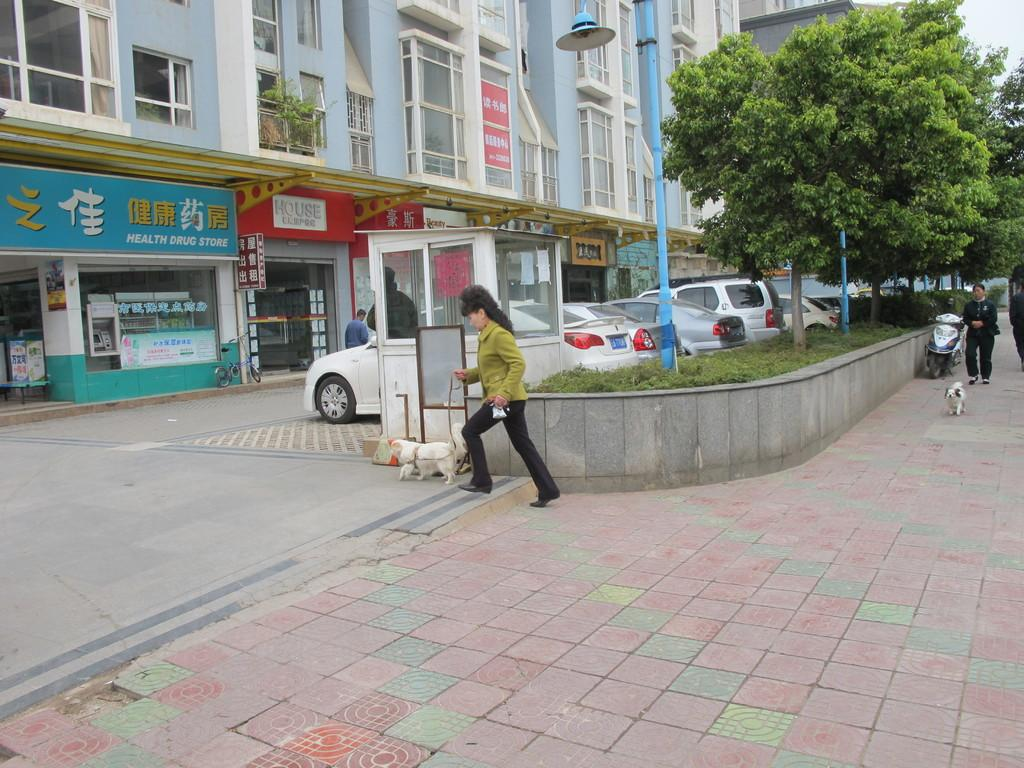What feature can be seen on the building in the image? The building has windows. What type of establishment is located in the building? There are stores in the building. What is present in front of the building? Trees, light poles, vehicles, and people are visible in front of the building. Can you describe the presence of a dog in the image? Yes, there is a dog in the image. What type of amusement can be seen in the image? There is no amusement present in the image; it features a building with stores, trees, light poles, vehicles, people, and a dog. How does the brush contribute to the image? There is no brush present in the image. 